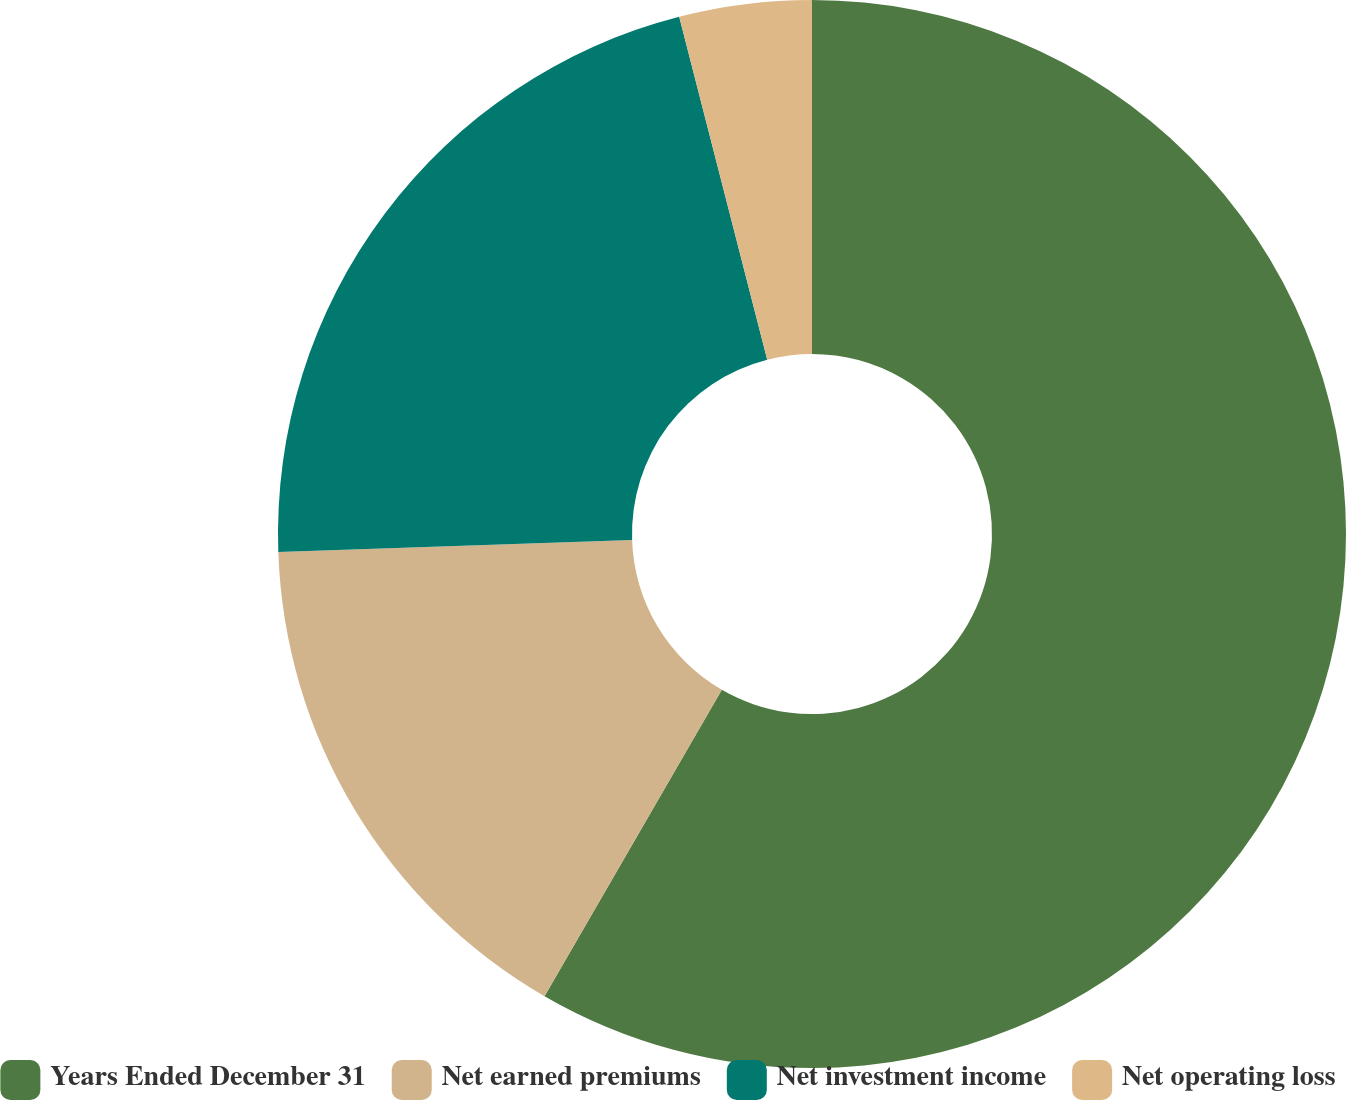<chart> <loc_0><loc_0><loc_500><loc_500><pie_chart><fcel>Years Ended December 31<fcel>Net earned premiums<fcel>Net investment income<fcel>Net operating loss<nl><fcel>58.35%<fcel>16.11%<fcel>21.54%<fcel>4.0%<nl></chart> 